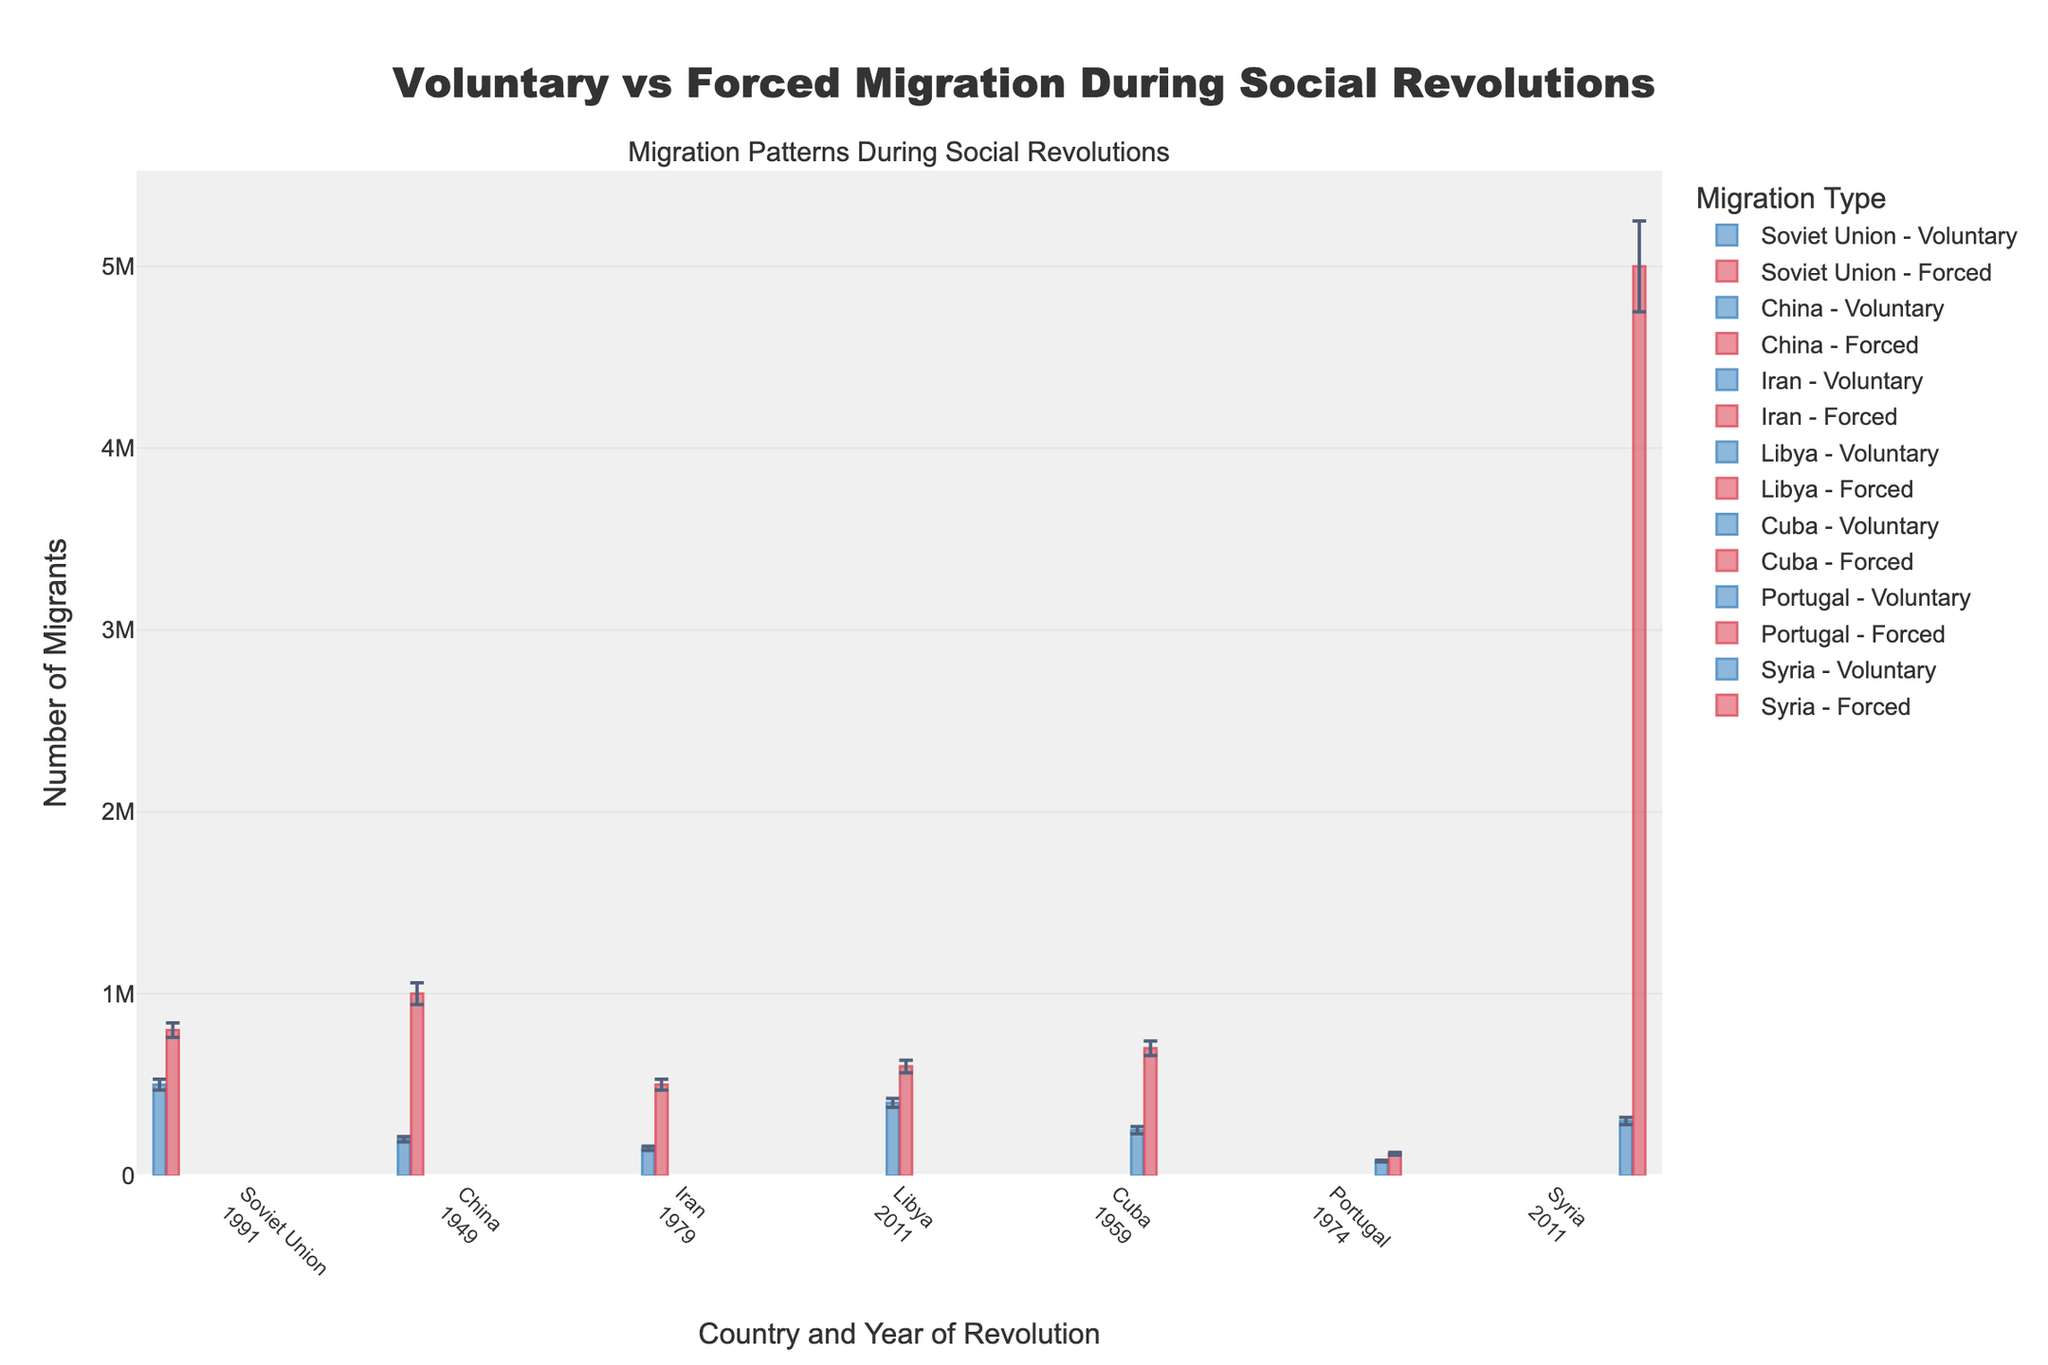How many types of migration are visualized in the plot? There are two types of migration visualized in the plot: voluntary and forced, as indicated by different colors in the bars of the plot.
Answer: 2 Which country and year combination shows the highest number of forced migrants? The Syria 2011 bar, which represents forced migration, is the tallest, indicating the highest number of forced migrants.
Answer: Syria 2011 What is the total number of voluntary migrants from the Soviet Union in 1991 and China in 1949? The Soviet Union in 1991 has 500,000 voluntary migrants and China in 1949 has 200,000 voluntary migrants. The total is 500,000 + 200,000 = 700,000.
Answer: 700,000 What is the difference between the number of forced migrants in Libya in 2011 and Portugal in 1974? Libya in 2011 has 600,000 forced migrants and Portugal in 1974 has 120,000 forced migrants. The difference is 600,000 - 120,000 = 480,000.
Answer: 480,000 Which country shows a higher error margin in forced migration: Cuba in 1959 or Soviet Union in 1991? The error margin for forced migration in Cuba in 1959 is 40,000 and in Soviet Union in 1991 is also 40,000. So, neither is higher; they are equal.
Answer: Equal What is the range (maximum minus minimum) of voluntary migrants across all countries and years? The maximum number of voluntary migrants is 500,000 (Soviet Union 1991) and the minimum is 80,000 (Portugal 1974). The range is 500,000 - 80,000 = 420,000.
Answer: 420,000 Which has a larger disparity between voluntary and forced migration count: Iran in 1979 or Cuba in 1959? Iran in 1979 has voluntary migrants at 150,000 and forced at 500,000. Disparity = 500,000 - 150,000 = 350,000. Cuba in 1959 has voluntary at 250,000 and forced at 700,000. Disparity = 700,000 - 250,000 = 450,000. Cuba has a larger disparity.
Answer: Cuba What is the total number of migrants (both voluntary and forced) from China in 1949? Voluntary migrants from China in 1949 are 200,000 and forced are 1,000,000. Total = 200,000 + 1,000,000 = 1,200,000.
Answer: 1,200,000 By how much does the number of forced migrants in Syria in 2011 exceed the number of forced migrants in Iran in 1979? Forced migrants in Syria in 2011 are 5,000,000 and in Iran in 1979 are 500,000. The difference is 5,000,000 - 500,000 = 4,500,000.
Answer: 4,500,000 